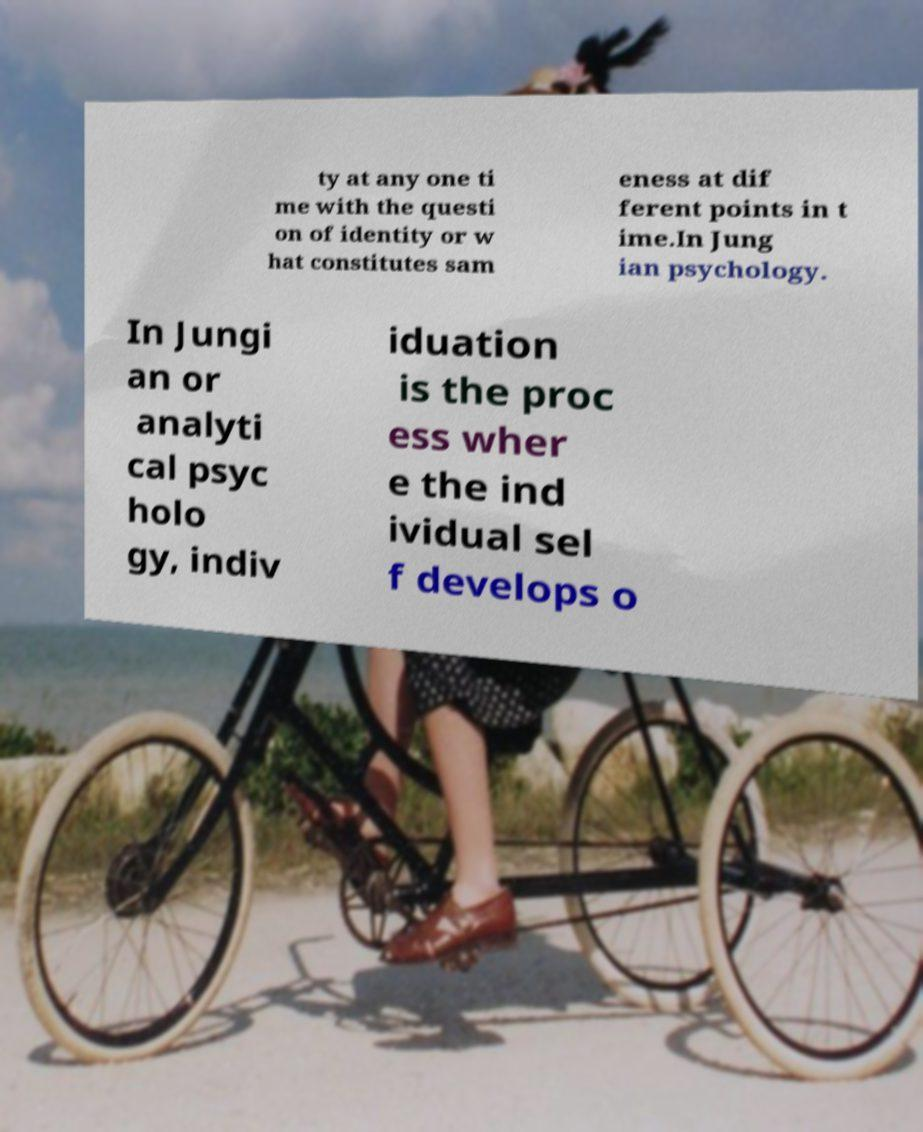Can you accurately transcribe the text from the provided image for me? ty at any one ti me with the questi on of identity or w hat constitutes sam eness at dif ferent points in t ime.In Jung ian psychology. In Jungi an or analyti cal psyc holo gy, indiv iduation is the proc ess wher e the ind ividual sel f develops o 